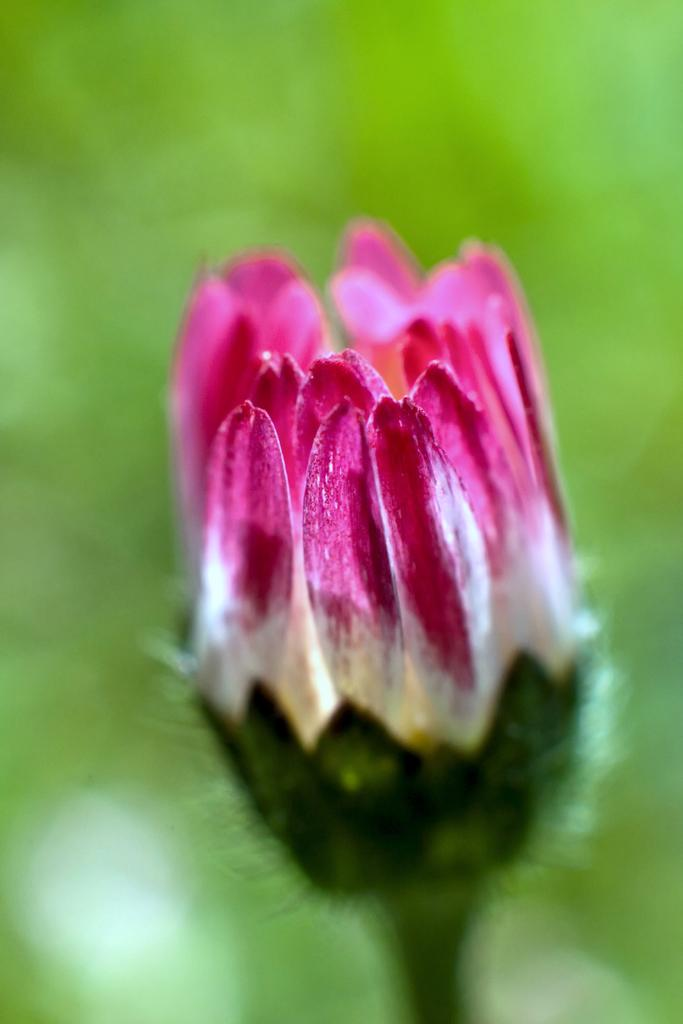What is the focus of the image? The image is zoomed in on a pink and white color flower in the foreground. What colors can be seen in the flower? The flower has pink and white colors. What is the color of the background in the image? The background of the image is green in color. How is the background of the image depicted? The background is blurry. Can you see any scissors cutting the butter in the image? There are no scissors or butter present in the image; it features a zoomed-in flower with a green background. What time of day is depicted in the image? The time of day cannot be determined from the image, as there are no specific indicators of time. 